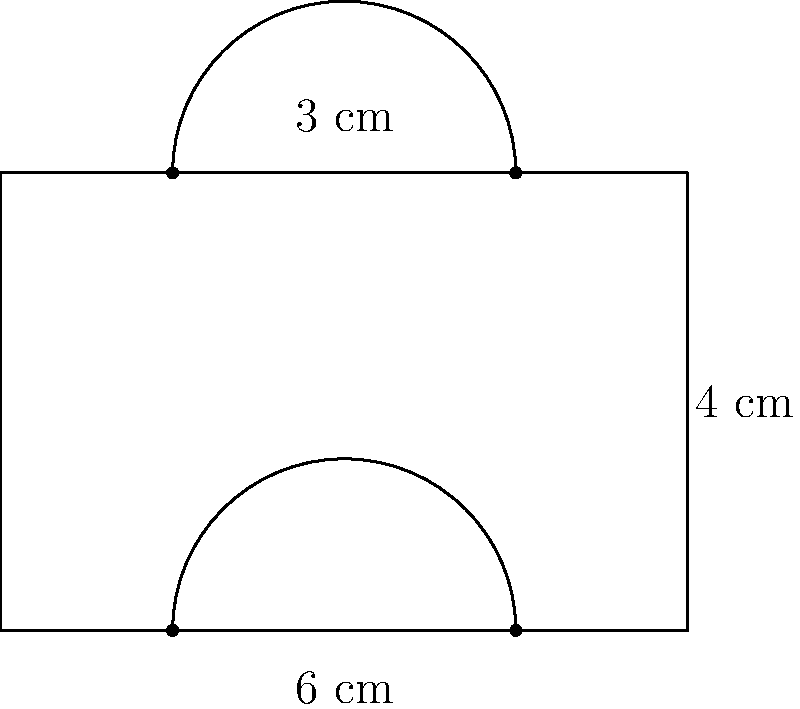Calculate the perimeter of the composite shape shown above, which consists of a rectangle with two semicircles attached to its top and bottom sides. The width of the rectangle is 6 cm, its height is 4 cm, and the diameter of each semicircle is 3 cm. Round your answer to two decimal places. To find the perimeter of this composite shape, we need to add the lengths of all outer edges:

1. Rectangle sides:
   - Left side: 4 cm
   - Right side: 4 cm
   - Top and bottom sides are replaced by semicircles, so we don't count them

2. Semicircles:
   - Each semicircle has a diameter of 3 cm
   - The circumference of a full circle is $\pi d$, where $d$ is the diameter
   - For a semicircle, we take half of this: $\frac{1}{2} \pi d$
   - For each semicircle: $\frac{1}{2} \pi \cdot 3 = \frac{3\pi}{2}$ cm

3. Total perimeter:
   $$ \text{Perimeter} = 4 + 4 + \frac{3\pi}{2} + \frac{3\pi}{2} $$
   $$ = 8 + 3\pi \text{ cm} $$

4. Calculating the numerical value:
   $$ 8 + 3 \cdot 3.14159... \approx 17.4248... \text{ cm} $$

5. Rounding to two decimal places:
   $$ 17.42 \text{ cm} $$
Answer: 17.42 cm 